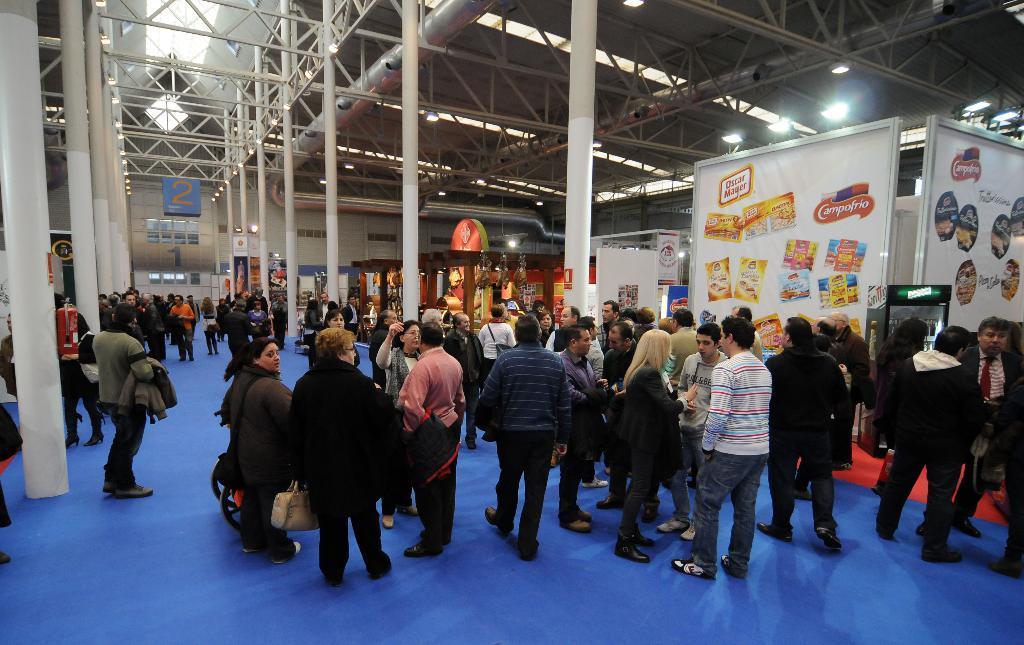In one or two sentences, can you explain what this image depicts? In this images we can see few persons are standing and walking on the floor and among them few are carrying bags and jackets in their hands. In the background we can see poles, lights on the ceiling, hoardings, machines and objects. 